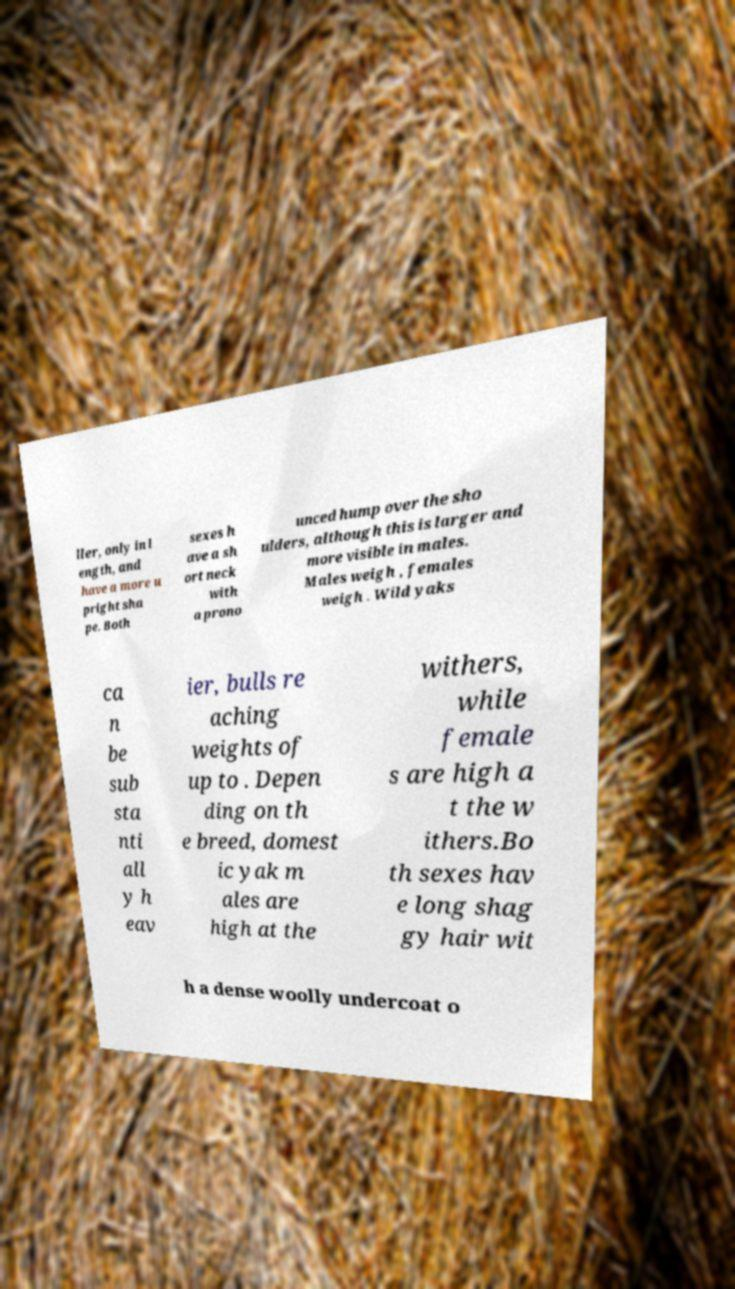Can you accurately transcribe the text from the provided image for me? ller, only in l ength, and have a more u pright sha pe. Both sexes h ave a sh ort neck with a prono unced hump over the sho ulders, although this is larger and more visible in males. Males weigh , females weigh . Wild yaks ca n be sub sta nti all y h eav ier, bulls re aching weights of up to . Depen ding on th e breed, domest ic yak m ales are high at the withers, while female s are high a t the w ithers.Bo th sexes hav e long shag gy hair wit h a dense woolly undercoat o 